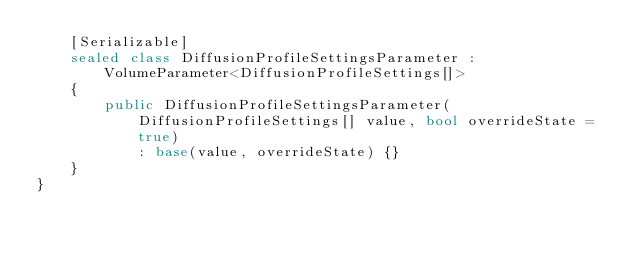Convert code to text. <code><loc_0><loc_0><loc_500><loc_500><_C#_>    [Serializable]
    sealed class DiffusionProfileSettingsParameter : VolumeParameter<DiffusionProfileSettings[]>
    {
        public DiffusionProfileSettingsParameter(DiffusionProfileSettings[] value, bool overrideState = true)
            : base(value, overrideState) {}
    }
}
</code> 